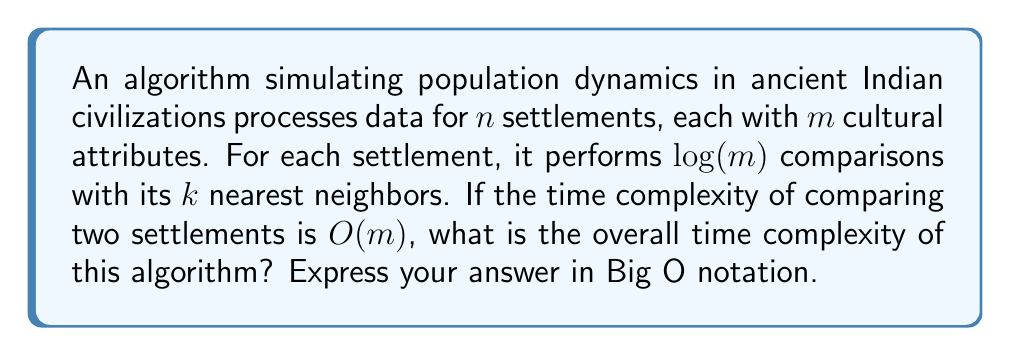Can you solve this math problem? Let's break down the problem and analyze it step by step:

1. We have $n$ settlements, each with $m$ cultural attributes.

2. For each settlement, the algorithm performs comparisons with its $k$ nearest neighbors.

3. The number of comparisons for each settlement is $\log(m)$.

4. The time complexity of comparing two settlements is $O(m)$.

Now, let's calculate the time complexity:

1. For each settlement (total $n$):
   - It performs $k$ comparisons with neighbors
   - Each comparison involves $\log(m)$ operations
   - Each operation takes $O(m)$ time

2. Therefore, for a single settlement, the time complexity is:
   $O(k \cdot \log(m) \cdot m)$

3. Since this is done for all $n$ settlements, we multiply by $n$:
   $O(n \cdot k \cdot \log(m) \cdot m)$

4. Simplifying the expression:
   $O(nkm\log(m))$

5. Since $k$ is typically a constant in nearest neighbor algorithms, we can remove it from the Big O notation:
   $O(nm\log(m))$

This final expression represents the overall time complexity of the algorithm.
Answer: $O(nm\log(m))$ 